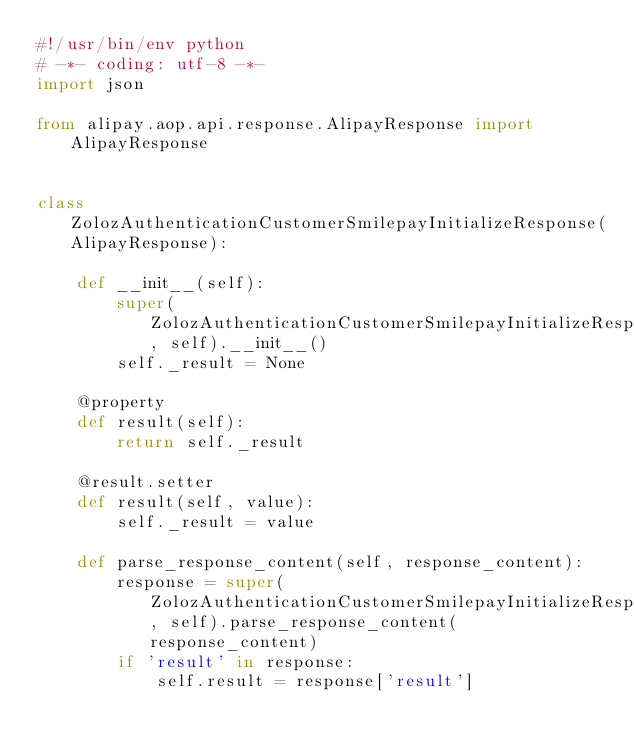Convert code to text. <code><loc_0><loc_0><loc_500><loc_500><_Python_>#!/usr/bin/env python
# -*- coding: utf-8 -*-
import json

from alipay.aop.api.response.AlipayResponse import AlipayResponse


class ZolozAuthenticationCustomerSmilepayInitializeResponse(AlipayResponse):

    def __init__(self):
        super(ZolozAuthenticationCustomerSmilepayInitializeResponse, self).__init__()
        self._result = None

    @property
    def result(self):
        return self._result

    @result.setter
    def result(self, value):
        self._result = value

    def parse_response_content(self, response_content):
        response = super(ZolozAuthenticationCustomerSmilepayInitializeResponse, self).parse_response_content(response_content)
        if 'result' in response:
            self.result = response['result']
</code> 